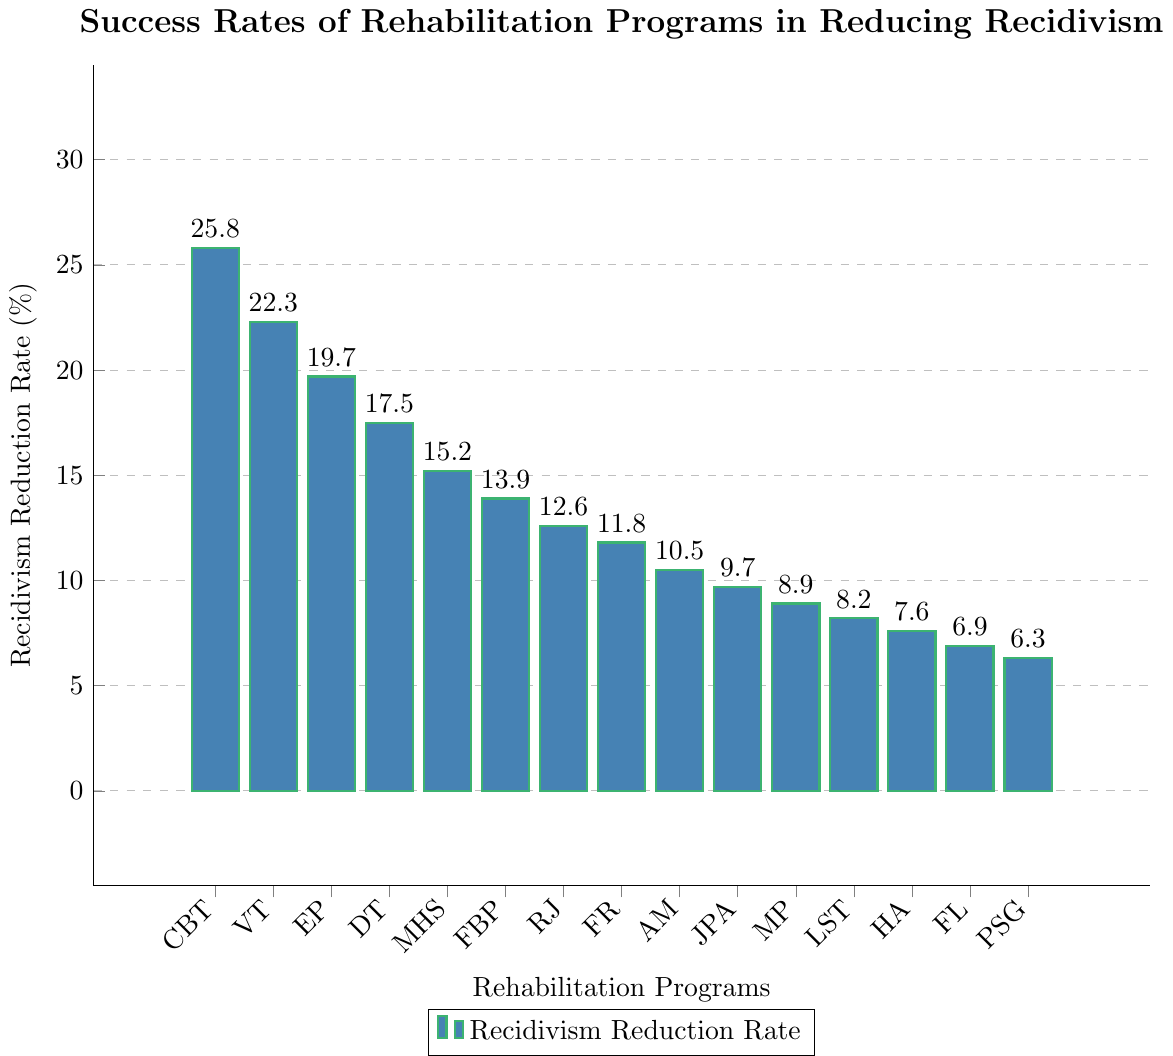What is the recidivism reduction rate for Cognitive-Behavioral Therapy? Look for the bar labeled "CBT"; its height represents the recidivism reduction rate for Cognitive-Behavioral Therapy.
Answer: 25.8% Which program has the lowest recidivism reduction rate? Identify the shortest bar in the chart, which corresponds to the program with the lowest rate.
Answer: Peer Support Groups (6.3%) How much higher is the recidivism reduction rate for Vocational Training compared to Family Reunification? Find the heights of the bars for Vocational Training (22.3%) and Family Reunification (11.8%), then subtract the latter from the former.
Answer: 10.5% What is the combined recidivism reduction rate of Drug Treatment, Mental Health Services, and Faith-Based Programs? Add the rates for Drug Treatment (17.5%), Mental Health Services (15.2%), and Faith-Based Programs (13.9%).
Answer: 46.6% Which program has a higher recidivism reduction rate: Education Programs or Job Placement Assistance? Compare the heights of the bars for Education Programs (19.7%) and Job Placement Assistance (9.7%).
Answer: Education Programs (19.7%) What is the average recidivism reduction rate for the top three programs? Identify the top three programs (CBT, VT, EP) and calculate the average of their rates: (25.8% + 22.3% + 19.7%)/3.
Answer: 22.6% Is Mental Health Services' recidivism reduction rate greater than twice that of Peer Support Groups? Compare whether 15.2% (Mental Health Services) is greater than double 6.3% (Peer Support Groups).
Answer: Yes, 15.2% is greater than 12.6% Which programs have a recidivism reduction rate lower than 10%? List all programs whose bars have heights below the 10% threshold: Job Placement Assistance (9.7%), Mentoring Programs (8.9%), Life Skills Training (8.2%), Housing Assistance (7.6%), Financial Literacy (6.9%), Peer Support Groups (6.3%).
Answer: Job Placement Assistance, Mentoring Programs, Life Skills Training, Housing Assistance, Financial Literacy, Peer Support Groups How many programs have a recidivism reduction rate above 20%? Count the bars corresponding to programs with heights above the 20% mark: Cognitive-Behavioral Therapy (25.8%) and Vocational Training (22.3%).
Answer: 2 What is the difference in recidivism reduction rates between Anger Management and Family Reunification? Calculate the difference between 11.8% (Family Reunification) and 10.5% (Anger Management).
Answer: 1.3% 